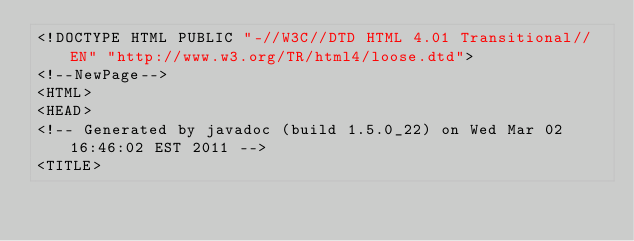Convert code to text. <code><loc_0><loc_0><loc_500><loc_500><_HTML_><!DOCTYPE HTML PUBLIC "-//W3C//DTD HTML 4.01 Transitional//EN" "http://www.w3.org/TR/html4/loose.dtd">
<!--NewPage-->
<HTML>
<HEAD>
<!-- Generated by javadoc (build 1.5.0_22) on Wed Mar 02 16:46:02 EST 2011 -->
<TITLE></code> 